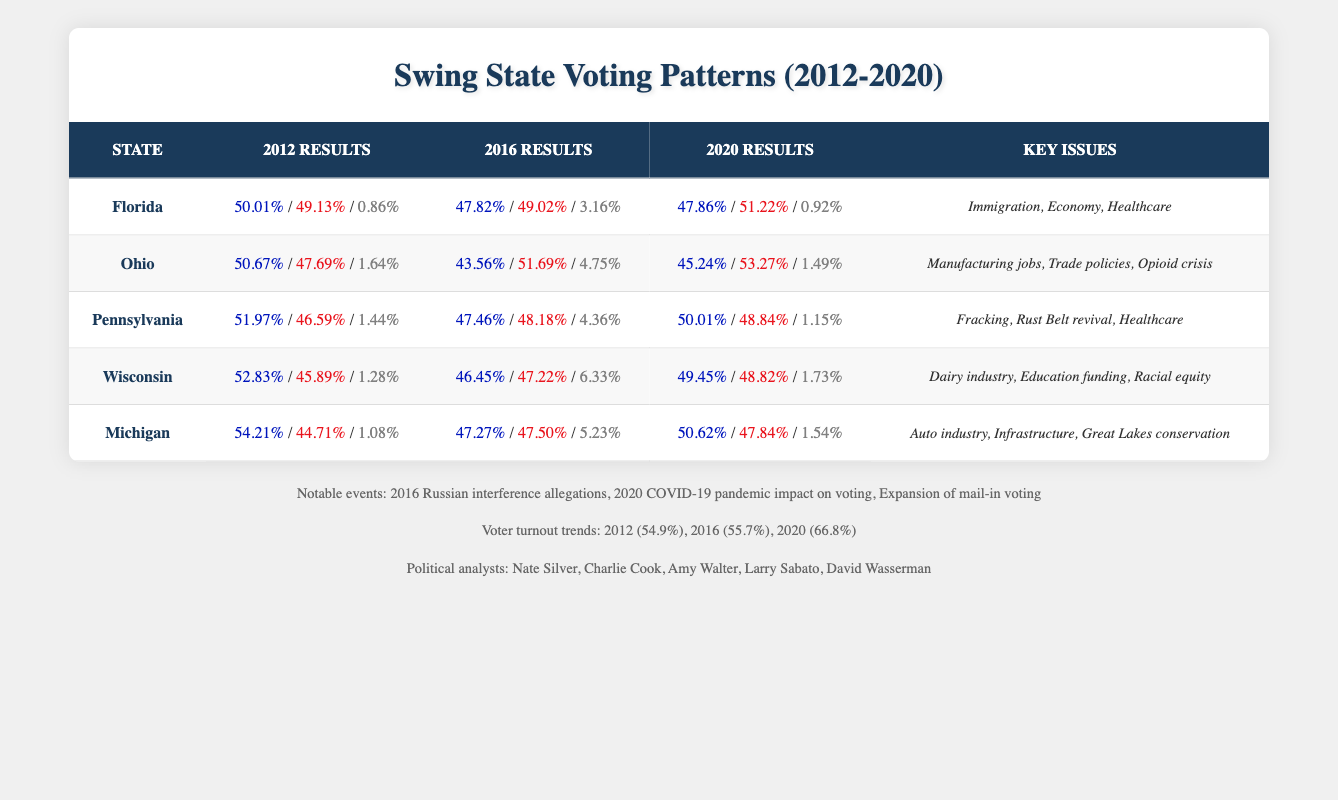What was the percentage of votes for the Democrats in Florida in 2016? According to the table, in the 2016 results for Florida, the Democrats received 47.82% of the votes.
Answer: 47.82% Which state had the highest percentage of votes for Democrats in 2012? In the table, Michigan shows the highest percentage of votes for Democrats in 2012 at 54.21%.
Answer: Michigan What is the total percentage of votes for Republicans in Ohio across all three elections? In Ohio, the Republican percentages for 2012, 2016, and 2020 are 47.69%, 51.69%, and 53.27%. Adding these gives: 47.69 + 51.69 + 53.27 = 152.65.
Answer: 152.65 Did voter turnout increase from 2012 to 2020? The voter turnout rates are 54.9% in 2012 and 66.8% in 2020. Since 66.8% is higher than 54.9%, the statement is true.
Answer: Yes Which state showed the most significant decrease in Democrat votes from 2012 to 2016? "Florida" had a decrease from 50.01% in 2012 to 47.82% in 2016. This is a decrease of 2.19%. This was the largest decrease when comparing the decrease in all states from 2012 to 2016.
Answer: Florida What are the key issues reported for Pennsylvania? The table states that the key issues for Pennsylvania include fracking, Rust Belt revival, and healthcare. These factors influenced voting behavior in the state.
Answer: Fracking, Rust Belt revival, Healthcare In which year did Wisconsin have the closest vote between Democrats and Republicans? Examining the votes in Wisconsin, the closest results occurred in 2020, where Democrats received 49.45% and Republicans 48.82%. The difference of 0.63% indicates a very tight race.
Answer: 2020 What percentage of votes did "other" candidates receive across all years in Michigan? For Michigan, the "other" candidates received 1.08% in 2012, 5.23% in 2016, and 1.54% in 2020. Adding these up gives a total of 1.08 + 5.23 + 1.54 = 7.85%.
Answer: 7.85% 